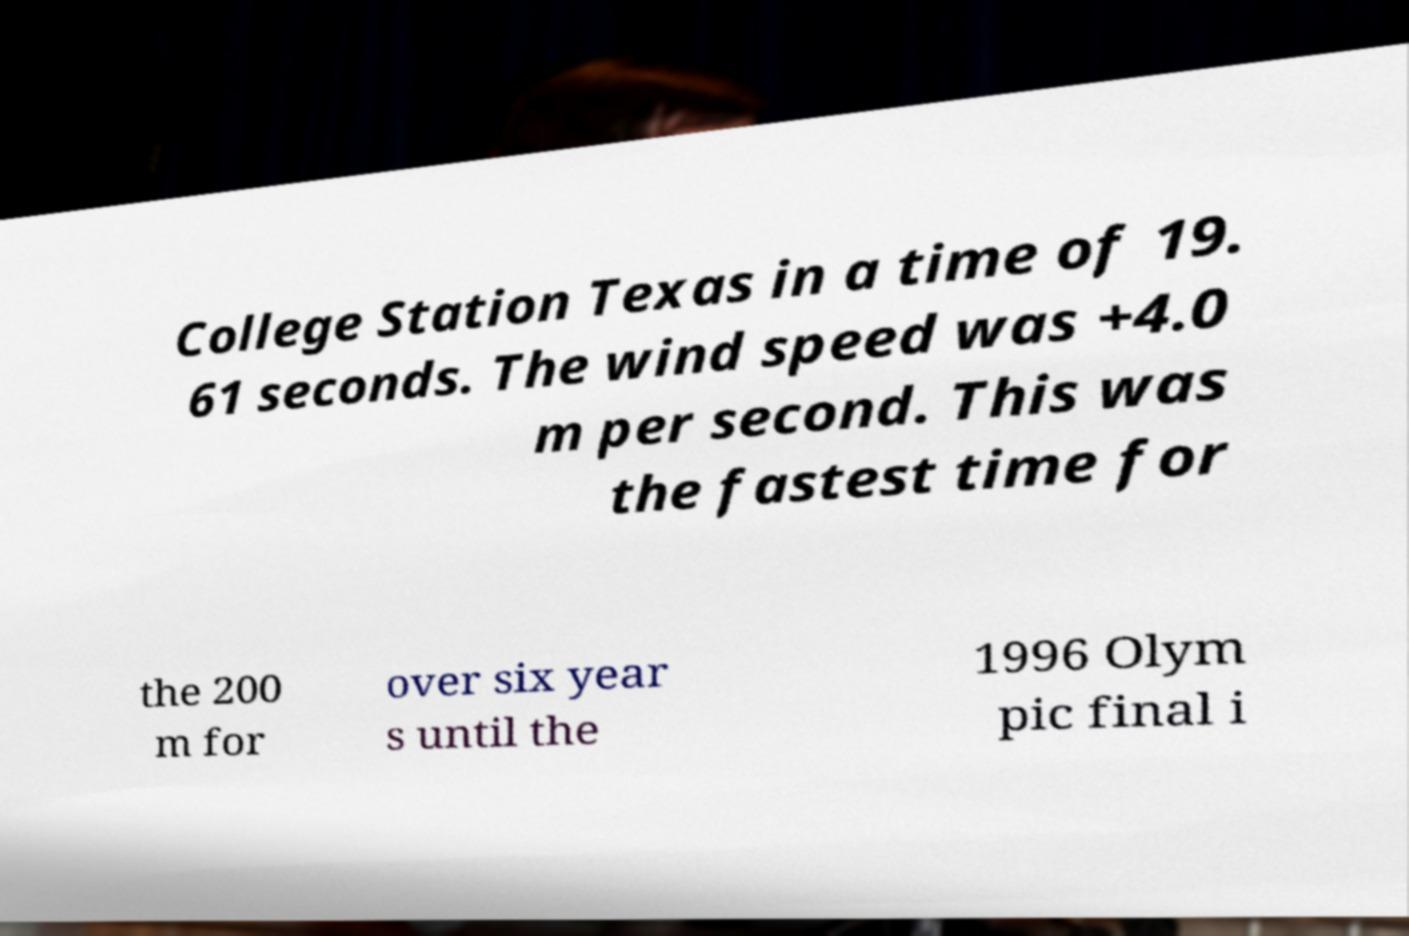There's text embedded in this image that I need extracted. Can you transcribe it verbatim? College Station Texas in a time of 19. 61 seconds. The wind speed was +4.0 m per second. This was the fastest time for the 200 m for over six year s until the 1996 Olym pic final i 